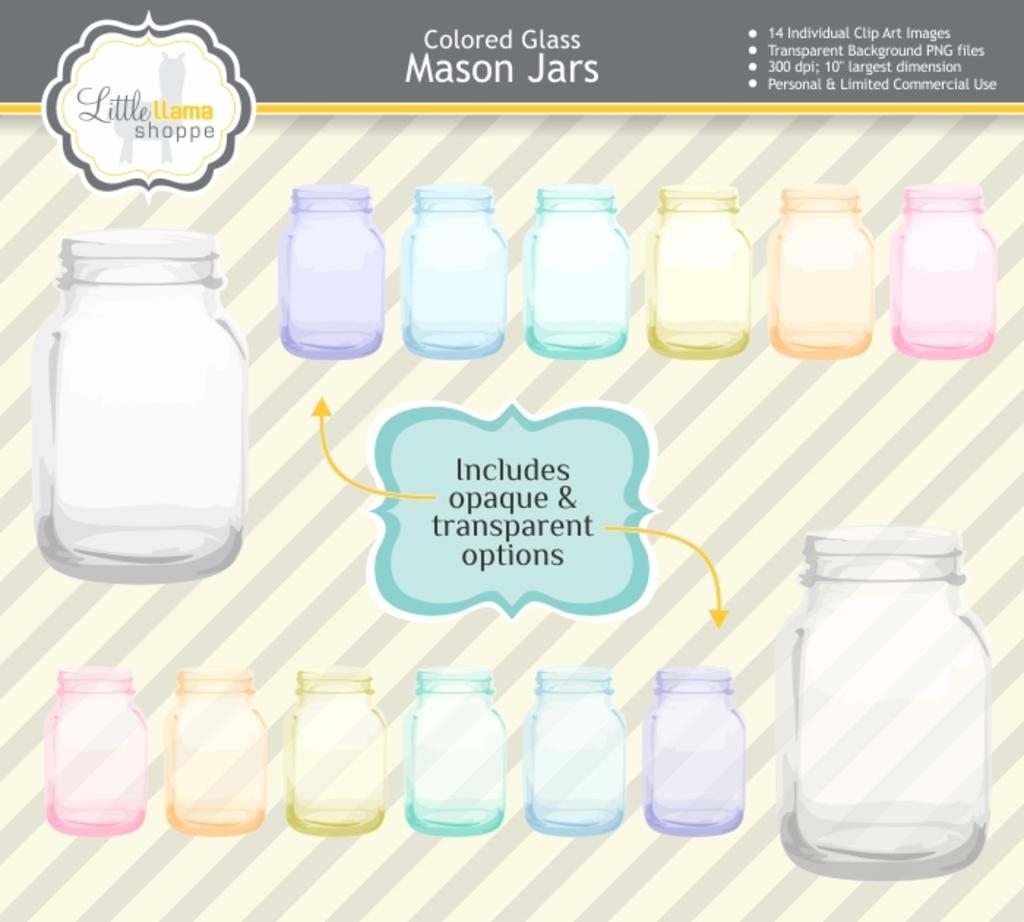What does it say in the centre of this page?
Your answer should be very brief. Includes opaque & transparent options. 